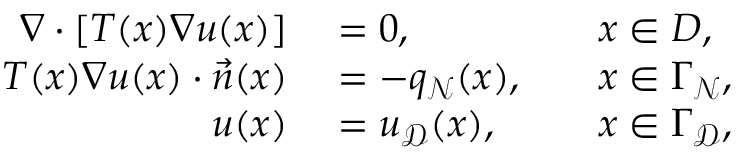<formula> <loc_0><loc_0><loc_500><loc_500>\begin{array} { r l r l } { \nabla \cdot \left [ T ( x ) \nabla u ( x ) \right ] } & = 0 , } & x \in D , } \\ { T ( x ) \nabla u ( x ) \cdot \vec { n } ( x ) } & = - q _ { \mathcal { N } } ( x ) , } & x \in \Gamma _ { \mathcal { N } } , } \\ { u ( x ) } & = u _ { \mathcal { D } } ( x ) , } & x \in \Gamma _ { \mathcal { D } } , } \end{array}</formula> 